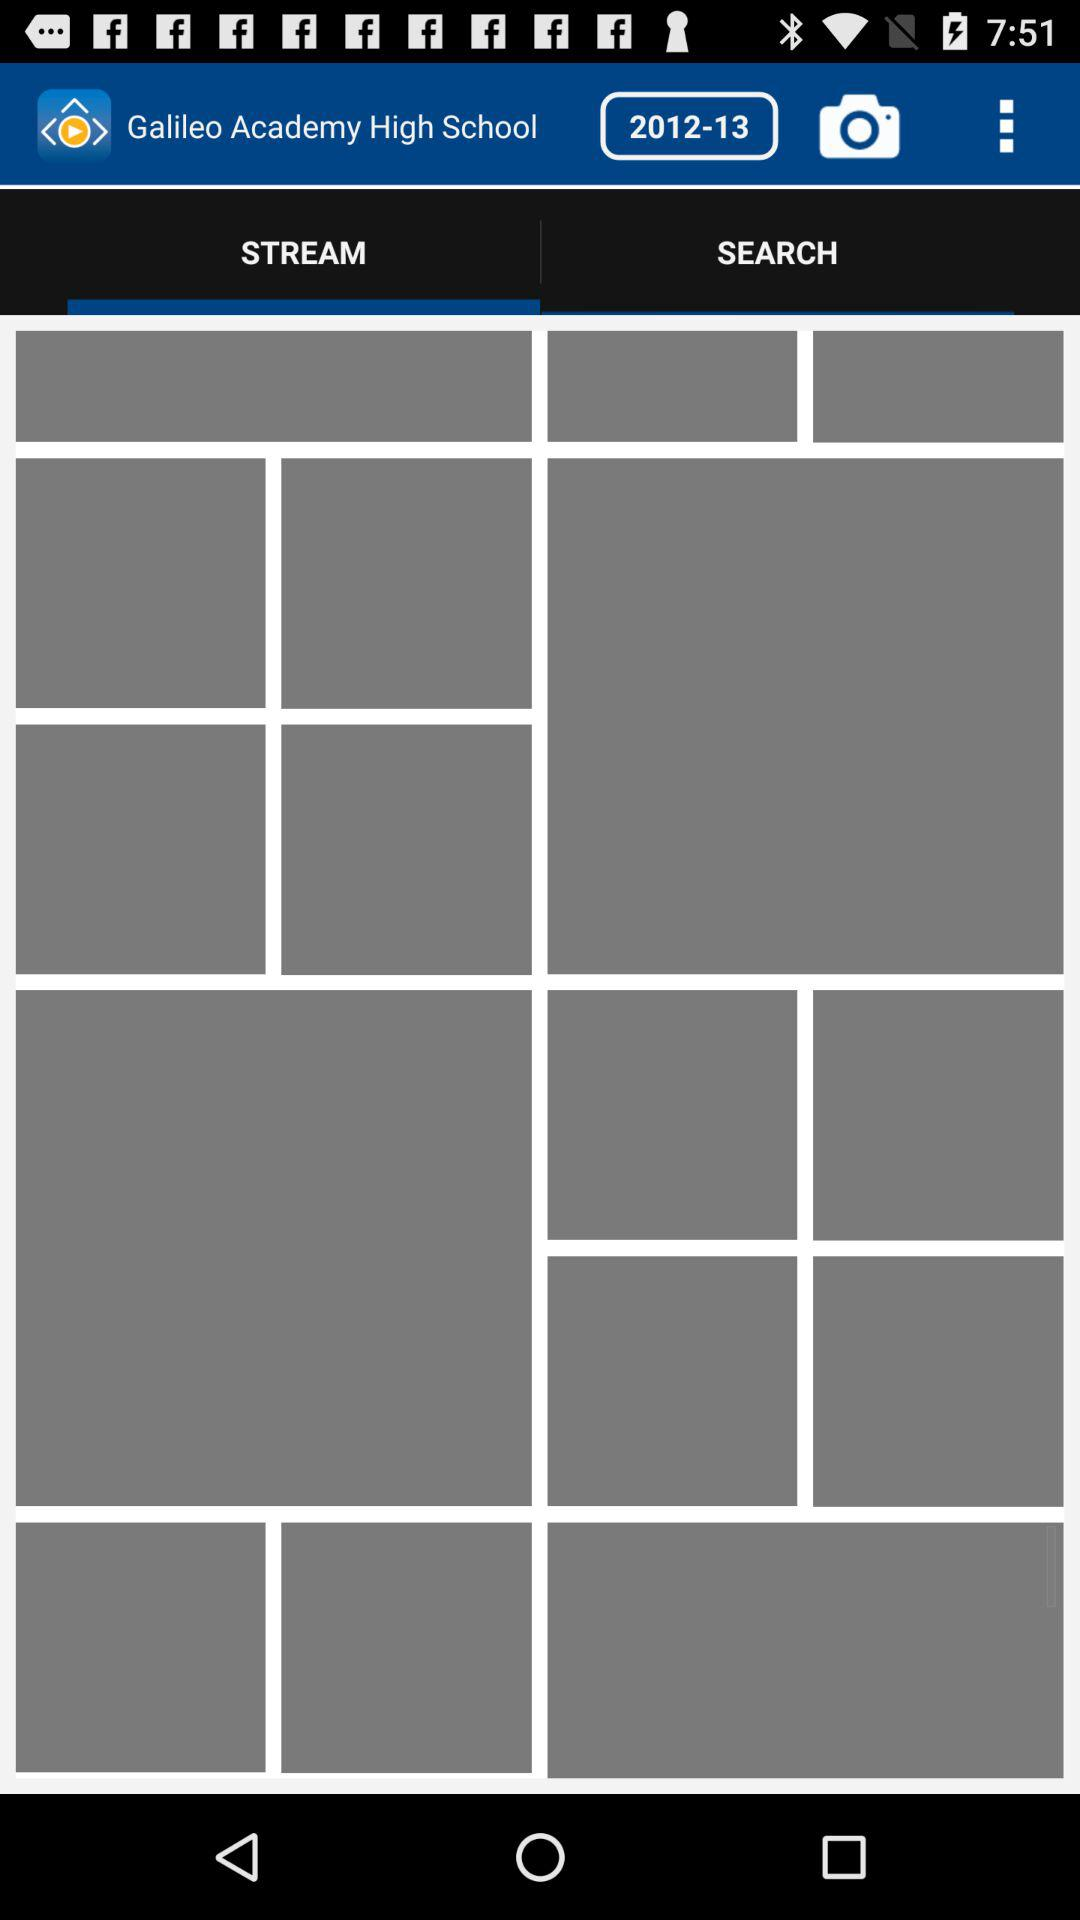What's the selected tab? The selected tab is "STREAM". 